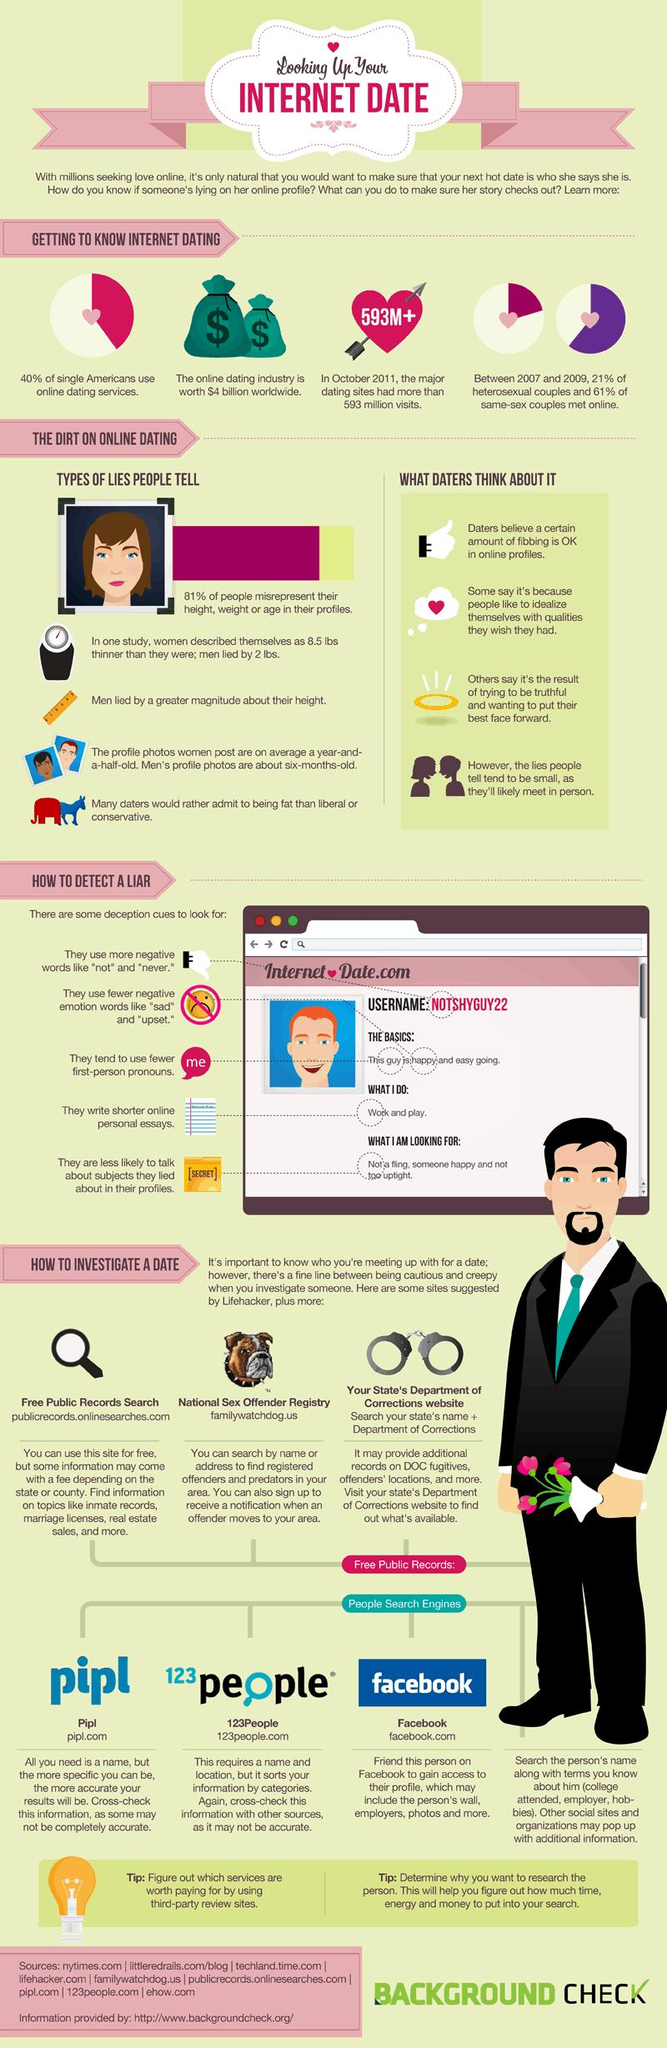Identify some key points in this picture. According to a recent survey, 60% of single Americans do not use online dating services. Nine sources are listed at the bottom. 